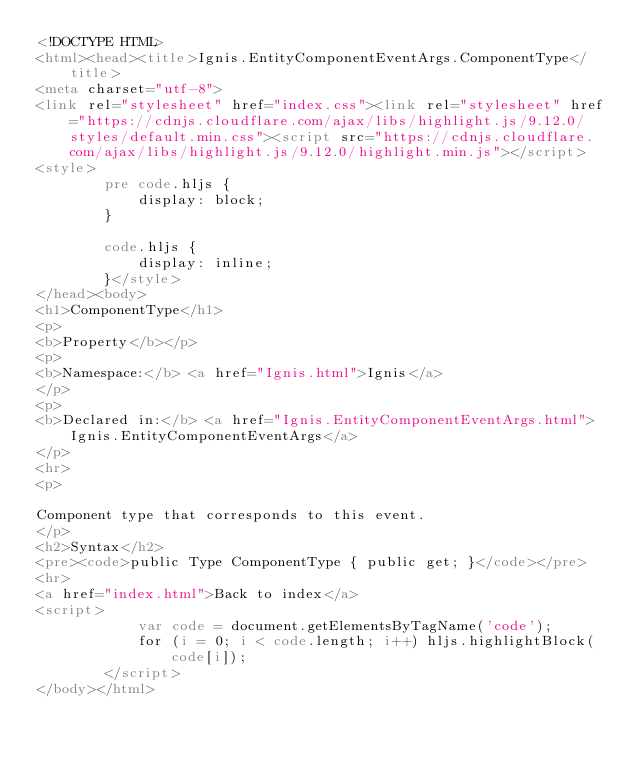Convert code to text. <code><loc_0><loc_0><loc_500><loc_500><_HTML_><!DOCTYPE HTML>
<html><head><title>Ignis.EntityComponentEventArgs.ComponentType</title>
<meta charset="utf-8">
<link rel="stylesheet" href="index.css"><link rel="stylesheet" href="https://cdnjs.cloudflare.com/ajax/libs/highlight.js/9.12.0/styles/default.min.css"><script src="https://cdnjs.cloudflare.com/ajax/libs/highlight.js/9.12.0/highlight.min.js"></script>
<style>
        pre code.hljs {
            display: block;
        }

        code.hljs {
            display: inline;
        }</style>
</head><body>
<h1>ComponentType</h1>
<p>
<b>Property</b></p>
<p>
<b>Namespace:</b> <a href="Ignis.html">Ignis</a>
</p>
<p>
<b>Declared in:</b> <a href="Ignis.EntityComponentEventArgs.html">Ignis.EntityComponentEventArgs</a>
</p>
<hr>
<p>

Component type that corresponds to this event.
</p>
<h2>Syntax</h2>
<pre><code>public Type ComponentType { public get; }</code></pre>
<hr>
<a href="index.html">Back to index</a>
<script>
            var code = document.getElementsByTagName('code');
            for (i = 0; i < code.length; i++) hljs.highlightBlock(code[i]);
        </script>
</body></html></code> 